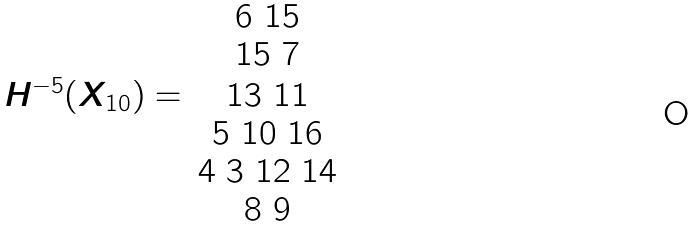Convert formula to latex. <formula><loc_0><loc_0><loc_500><loc_500>\begin{array} { c c } & 6 \ 1 5 \\ & 1 5 \ 7 \\ H ^ { - 5 } ( X _ { 1 0 } ) = & 1 3 \ 1 1 \\ & 5 \ 1 0 \ 1 6 \\ & 4 \ 3 \ 1 2 \ 1 4 \\ & 8 \ 9 \\ \end{array}</formula> 